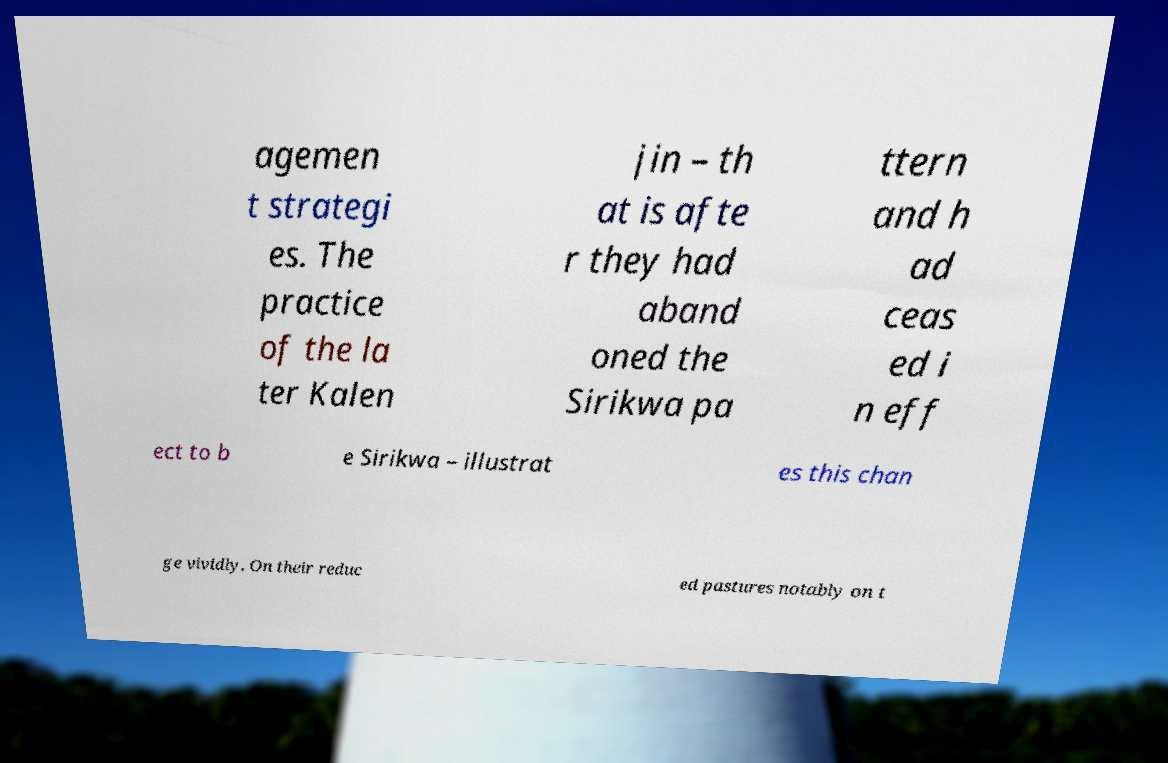Could you extract and type out the text from this image? agemen t strategi es. The practice of the la ter Kalen jin – th at is afte r they had aband oned the Sirikwa pa ttern and h ad ceas ed i n eff ect to b e Sirikwa – illustrat es this chan ge vividly. On their reduc ed pastures notably on t 